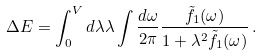<formula> <loc_0><loc_0><loc_500><loc_500>\Delta E = \int _ { 0 } ^ { V } d \lambda \lambda \int \frac { d \omega } { 2 \pi } \frac { \tilde { f } _ { 1 } ( \omega ) } { 1 + \lambda ^ { 2 } \tilde { f } _ { 1 } ( \omega ) } \, .</formula> 